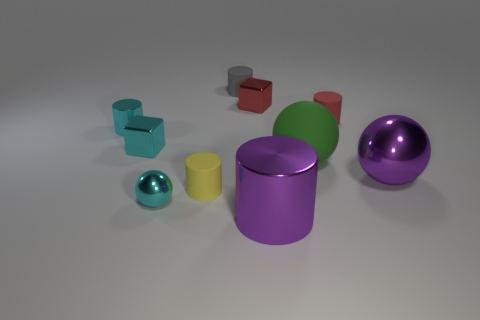There is a cylinder that is behind the small red cylinder; how many tiny matte things are left of it?
Provide a succinct answer. 1. How many other objects are the same shape as the small red matte object?
Ensure brevity in your answer.  4. There is a object that is the same color as the big cylinder; what material is it?
Offer a very short reply. Metal. What number of blocks have the same color as the big metallic ball?
Keep it short and to the point. 0. The tiny ball that is made of the same material as the large purple cylinder is what color?
Offer a terse response. Cyan. Are there any other cylinders that have the same size as the gray rubber cylinder?
Your answer should be compact. Yes. Is the number of small gray matte cylinders to the right of the red matte cylinder greater than the number of tiny cyan metal things on the right side of the small yellow thing?
Give a very brief answer. No. Does the block left of the tiny gray matte cylinder have the same material as the purple thing that is on the right side of the large purple metallic cylinder?
Give a very brief answer. Yes. There is a yellow matte thing that is the same size as the cyan sphere; what shape is it?
Your response must be concise. Cylinder. Are there any other red shiny objects that have the same shape as the tiny red metal object?
Your response must be concise. No. 